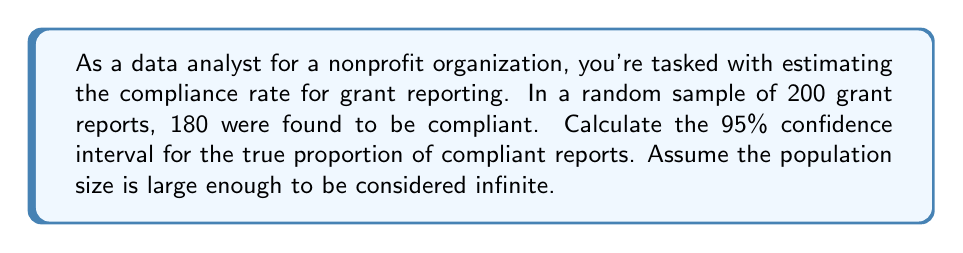Solve this math problem. To calculate the confidence interval for a proportion, we'll use the following steps:

1. Calculate the sample proportion:
   $\hat{p} = \frac{\text{number of successes}}{\text{sample size}} = \frac{180}{200} = 0.9$

2. Calculate the standard error of the proportion:
   $SE = \sqrt{\frac{\hat{p}(1-\hat{p})}{n}} = \sqrt{\frac{0.9(1-0.9)}{200}} = \sqrt{\frac{0.09}{200}} = 0.0212$

3. For a 95% confidence interval, use the z-score of 1.96 (from the standard normal distribution).

4. Calculate the margin of error:
   $\text{Margin of Error} = z \times SE = 1.96 \times 0.0212 = 0.0416$

5. Calculate the confidence interval:
   $\text{CI} = \hat{p} \pm \text{Margin of Error}$
   $\text{CI} = 0.9 \pm 0.0416$
   $\text{Lower bound} = 0.9 - 0.0416 = 0.8584$
   $\text{Upper bound} = 0.9 + 0.0416 = 0.9416$

Therefore, the 95% confidence interval is (0.8584, 0.9416).

Interpretation: We can be 95% confident that the true proportion of compliant grant reports in the population falls between 85.84% and 94.16%.
Answer: The 95% confidence interval for the true proportion of compliant grant reports is (0.8584, 0.9416) or (85.84%, 94.16%). 